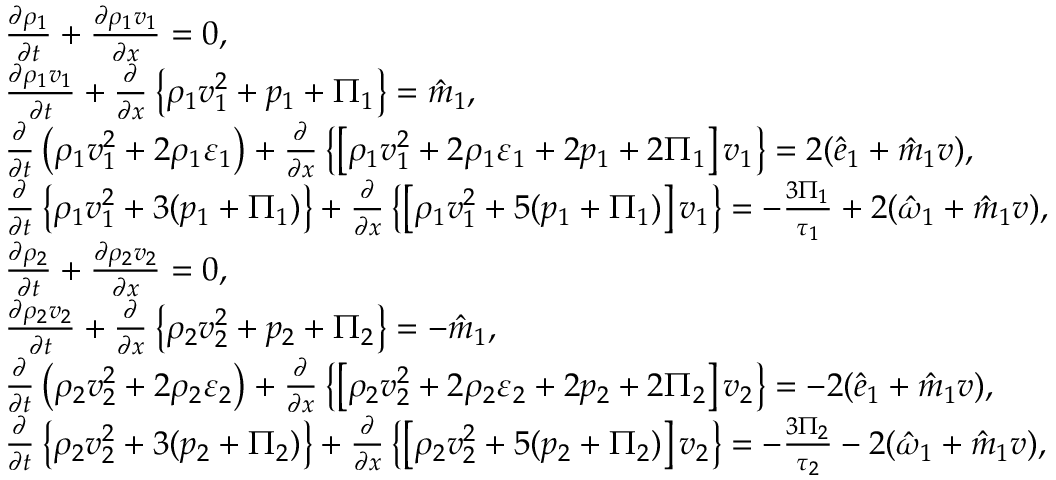<formula> <loc_0><loc_0><loc_500><loc_500>\begin{array} { r l } & { \frac { \partial \rho _ { 1 } } { \partial t } + \frac { \partial \rho _ { 1 } v _ { 1 } } { \partial x } = 0 , } \\ & { \frac { \partial \rho _ { 1 } v _ { 1 } } { \partial t } + \frac { \partial } { \partial x } \left \{ \rho _ { 1 } v _ { 1 } ^ { 2 } + p _ { 1 } + \Pi _ { 1 } \right \} = \hat { m } _ { 1 } , } \\ & { \frac { \partial } { \partial t } \left ( \rho _ { 1 } v _ { 1 } ^ { 2 } + 2 \rho _ { 1 } \varepsilon _ { 1 } \right ) + \frac { \partial } { \partial x } \left \{ \left [ \rho _ { 1 } v _ { 1 } ^ { 2 } + 2 \rho _ { 1 } \varepsilon _ { 1 } + 2 p _ { 1 } + 2 \Pi _ { 1 } \right ] v _ { 1 } \right \} = 2 ( \hat { e } _ { 1 } + \hat { m } _ { 1 } v ) , } \\ & { \frac { \partial } { \partial t } \left \{ \rho _ { 1 } v _ { 1 } ^ { 2 } + 3 ( p _ { 1 } + \Pi _ { 1 } ) \right \} + \frac { \partial } { \partial x } \left \{ \left [ \rho _ { 1 } v _ { 1 } ^ { 2 } + 5 ( p _ { 1 } + \Pi _ { 1 } ) \right ] v _ { 1 } \right \} = - \frac { 3 \Pi _ { 1 } } { \tau _ { 1 } } + 2 ( \hat { \omega } _ { 1 } + \hat { m } _ { 1 } v ) , } \\ & { \frac { \partial \rho _ { 2 } } { \partial t } + \frac { \partial \rho _ { 2 } v _ { 2 } } { \partial x } = 0 , } \\ & { \frac { \partial \rho _ { 2 } v _ { 2 } } { \partial t } + \frac { \partial } { \partial x } \left \{ \rho _ { 2 } v _ { 2 } ^ { 2 } + p _ { 2 } + \Pi _ { 2 } \right \} = - \hat { m } _ { 1 } , } \\ & { \frac { \partial } { \partial t } \left ( \rho _ { 2 } v _ { 2 } ^ { 2 } + 2 \rho _ { 2 } \varepsilon _ { 2 } \right ) + \frac { \partial } { \partial x } \left \{ \left [ \rho _ { 2 } v _ { 2 } ^ { 2 } + 2 \rho _ { 2 } \varepsilon _ { 2 } + 2 p _ { 2 } + 2 \Pi _ { 2 } \right ] v _ { 2 } \right \} = - 2 ( \hat { e } _ { 1 } + \hat { m } _ { 1 } v ) , } \\ & { \frac { \partial } { \partial t } \left \{ \rho _ { 2 } v _ { 2 } ^ { 2 } + 3 ( p _ { 2 } + \Pi _ { 2 } ) \right \} + \frac { \partial } { \partial x } \left \{ \left [ \rho _ { 2 } v _ { 2 } ^ { 2 } + 5 ( p _ { 2 } + \Pi _ { 2 } ) \right ] v _ { 2 } \right \} = - \frac { 3 \Pi _ { 2 } } { \tau _ { 2 } } - 2 ( \hat { \omega } _ { 1 } + \hat { m } _ { 1 } v ) , } \end{array}</formula> 